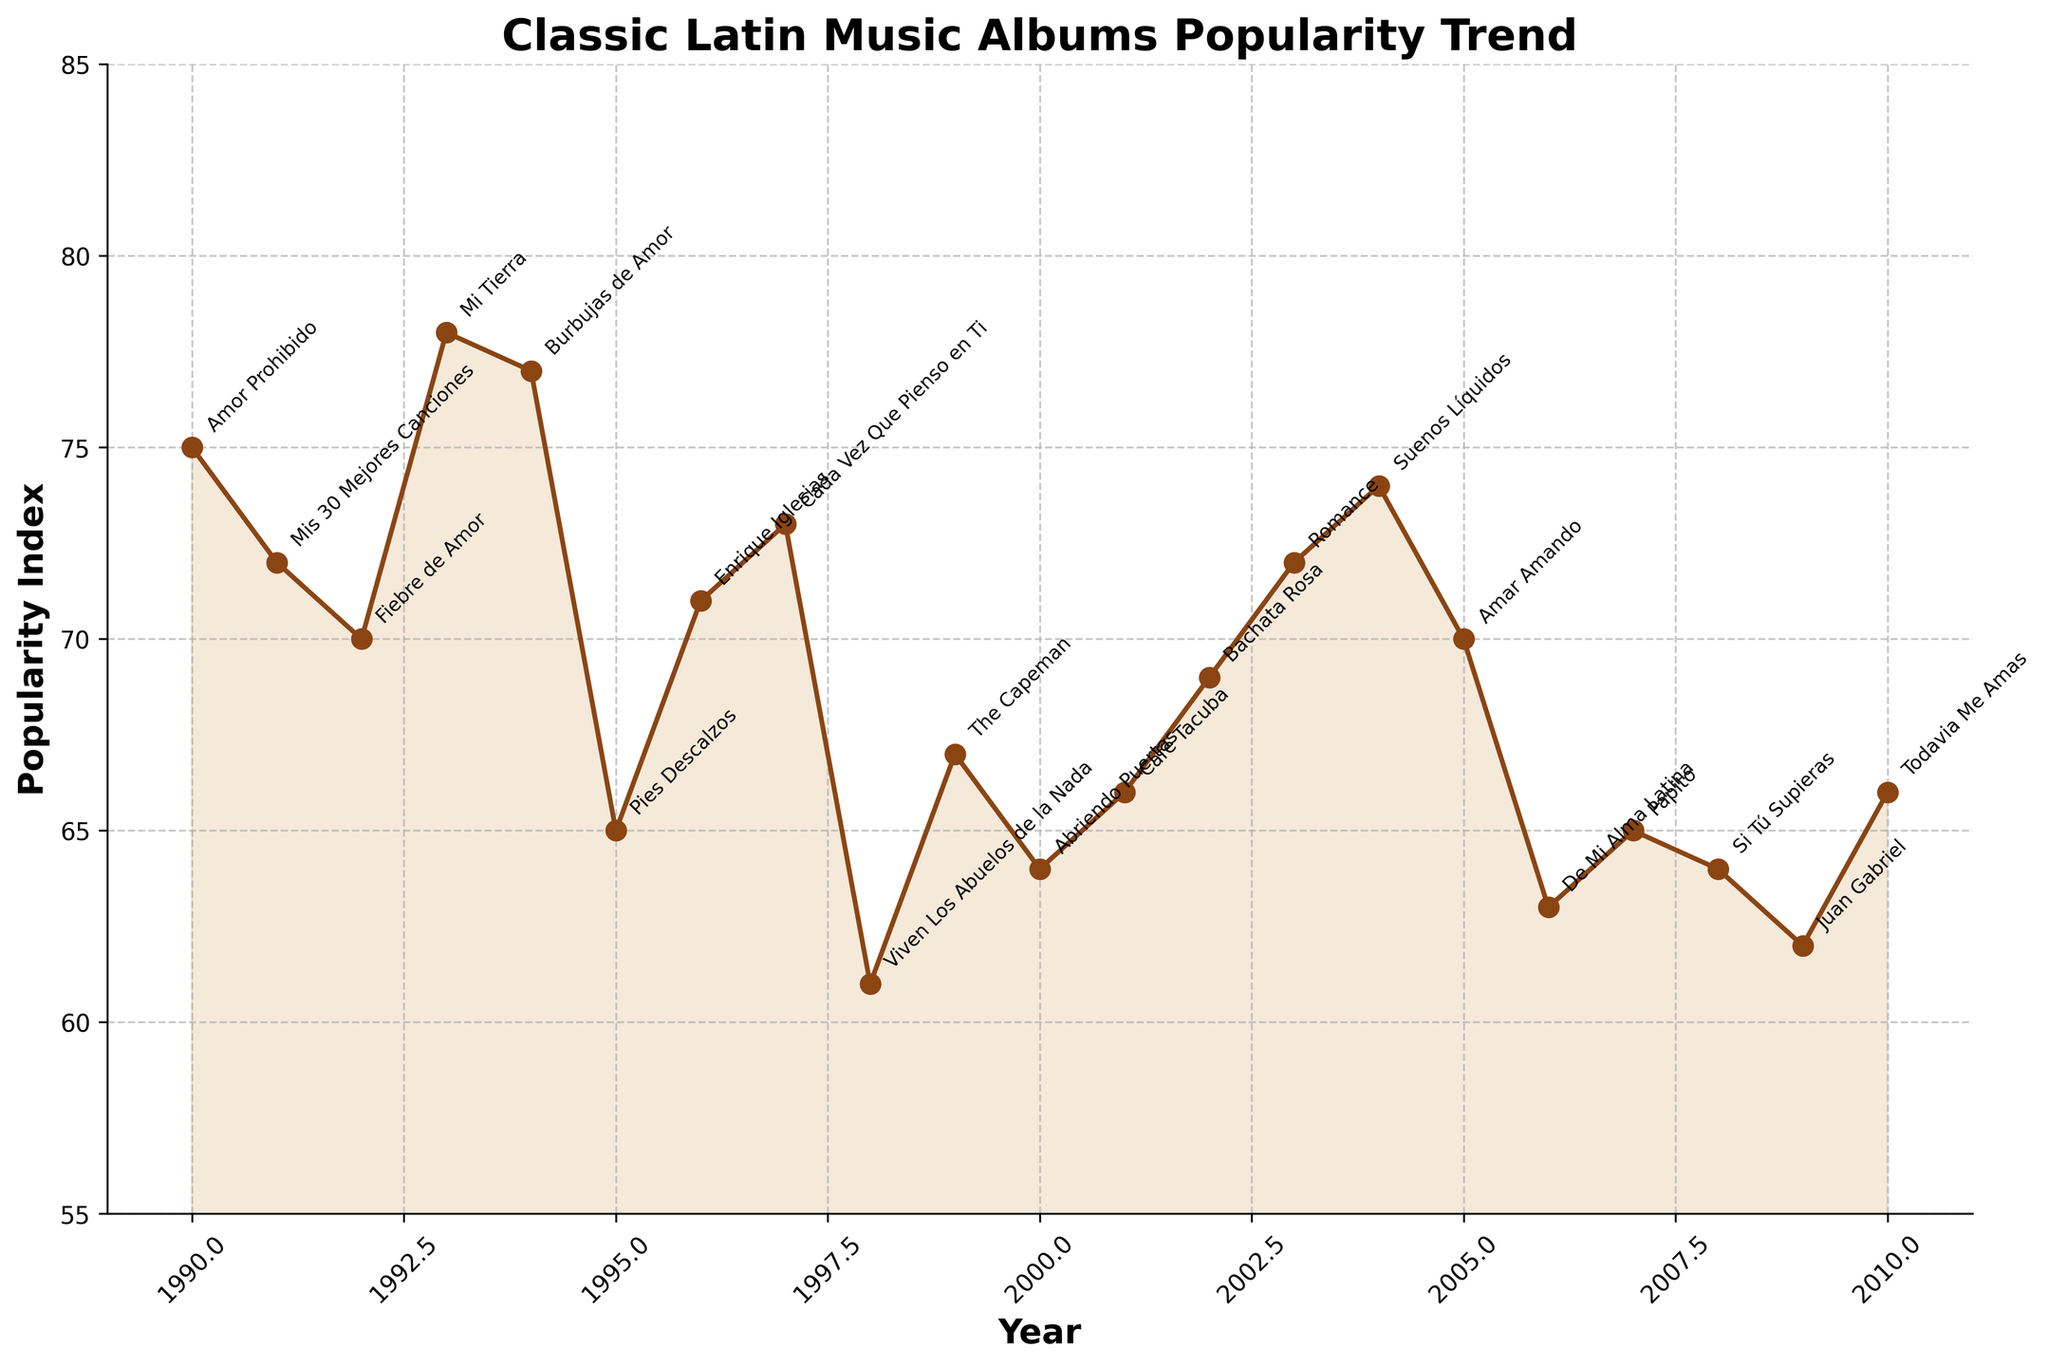What is the title of the plot? The title of the plot is written at the very top of the figure.
Answer: Classic Latin Music Albums Popularity Trend How many years are represented in the plot? The x-axis represents the years from 1990 to 2010. Counting these years gives the number of years represented.
Answer: 21 What is the peak popularity index and in which year did it occur? By visually observing the y-axis, the highest point on the graph is around 78, which aligns with the year label of 1993.
Answer: 78 in 1993 Which album had the lowest popularity index and what was the value? The lowest point on the curve, observed on the y-axis, corresponds with "Viven Los Abuelos de la Nada" from 1998 with a value of 61.
Answer: Viven Los Abuelos de la Nada; 61 Which two years had the same popularity index and what is the value? The curve has multiple points at the same height. The years 1991 and 2003 both show 72 on the y-axis.
Answer: 1991 and 2003; 72 What is the average popularity index from 1990 to 2010? Sum the popularity indices from each year and divide by the number of years (21). Calculation: (75+72+70+78+77+65+71+73+61+67+64+66+69+72+74+70+63+65+64+62+66)/21 = 68.38
Answer: 68.38 Between 1990 and 1995, which album had the highest popularity index? The first six data points (1990-1995) show that "Mi Tierra" by Gloria Estefan in 1993 has the highest value at 78.
Answer: Mi Tierra by Gloria Estefan Which artist appears most frequently on the plot? By counting the occurrences of each artist's name in the annotations, Gloria Estefan and Luis Miguel both appear twice.
Answer: Gloria Estefan, Luis Miguel How does the popularity trend change between 2005 and 2010? From 2005 to 2010, the popularity indices show a slight decrease, with values: 70 (2005), 63 (2006), 65 (2007), 64 (2008), 62 (2009), 66 (2010).
Answer: Decreases Compare the popularity index of 1990 (Amor Prohibido) and 2010 (Todavia Me Amas). Notice the y-axis values for each year: 1990 has a value of 75 and 2010 has a value of 66. Thus, 1990 is higher by 9 points.
Answer: 1990 is higher by 9 points 